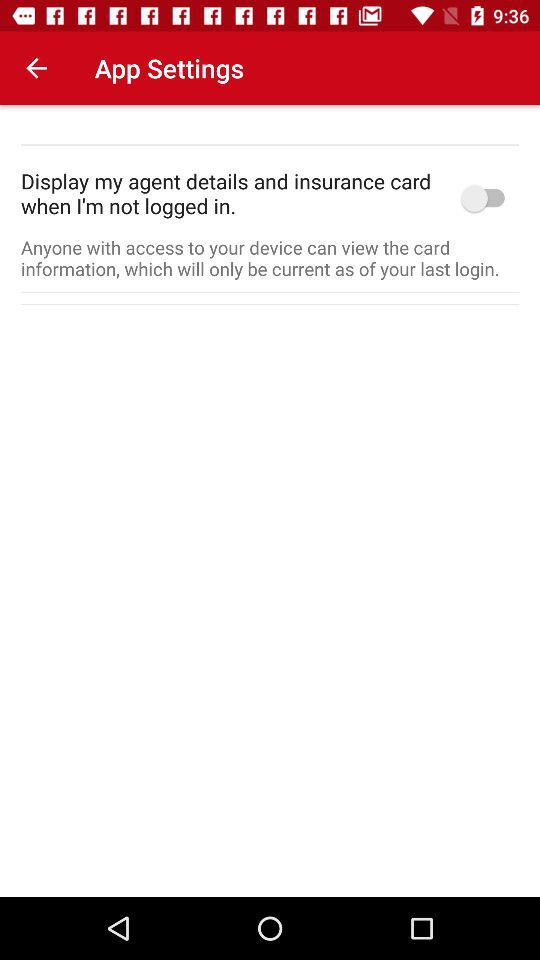What is the status of "Display my agent details and insurance card when I'm not logged in"? The status is "off". 